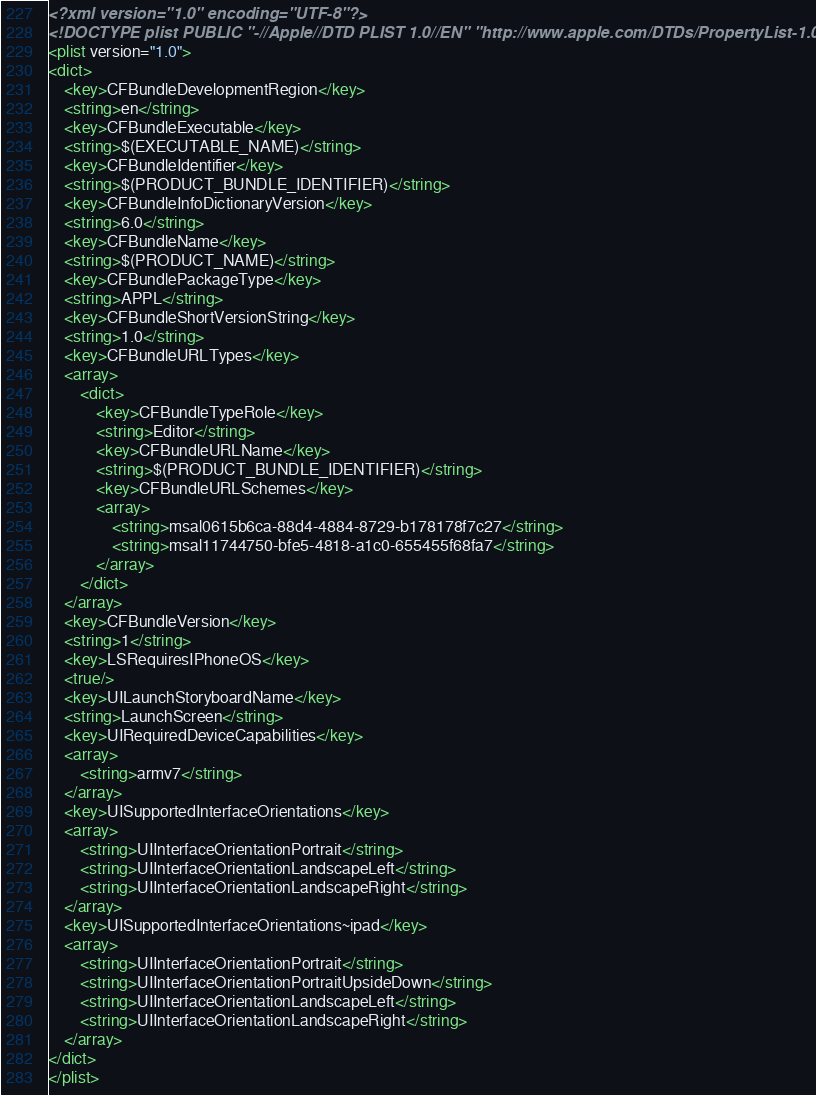<code> <loc_0><loc_0><loc_500><loc_500><_XML_><?xml version="1.0" encoding="UTF-8"?>
<!DOCTYPE plist PUBLIC "-//Apple//DTD PLIST 1.0//EN" "http://www.apple.com/DTDs/PropertyList-1.0.dtd">
<plist version="1.0">
<dict>
	<key>CFBundleDevelopmentRegion</key>
	<string>en</string>
	<key>CFBundleExecutable</key>
	<string>$(EXECUTABLE_NAME)</string>
	<key>CFBundleIdentifier</key>
	<string>$(PRODUCT_BUNDLE_IDENTIFIER)</string>
	<key>CFBundleInfoDictionaryVersion</key>
	<string>6.0</string>
	<key>CFBundleName</key>
	<string>$(PRODUCT_NAME)</string>
	<key>CFBundlePackageType</key>
	<string>APPL</string>
	<key>CFBundleShortVersionString</key>
	<string>1.0</string>
	<key>CFBundleURLTypes</key>
	<array>
		<dict>
			<key>CFBundleTypeRole</key>
			<string>Editor</string>
			<key>CFBundleURLName</key>
			<string>$(PRODUCT_BUNDLE_IDENTIFIER)</string>
			<key>CFBundleURLSchemes</key>
			<array>
				<string>msal0615b6ca-88d4-4884-8729-b178178f7c27</string>
				<string>msal11744750-bfe5-4818-a1c0-655455f68fa7</string>
			</array>
		</dict>
	</array>
	<key>CFBundleVersion</key>
	<string>1</string>
	<key>LSRequiresIPhoneOS</key>
	<true/>
	<key>UILaunchStoryboardName</key>
	<string>LaunchScreen</string>
	<key>UIRequiredDeviceCapabilities</key>
	<array>
		<string>armv7</string>
	</array>
	<key>UISupportedInterfaceOrientations</key>
	<array>
		<string>UIInterfaceOrientationPortrait</string>
		<string>UIInterfaceOrientationLandscapeLeft</string>
		<string>UIInterfaceOrientationLandscapeRight</string>
	</array>
	<key>UISupportedInterfaceOrientations~ipad</key>
	<array>
		<string>UIInterfaceOrientationPortrait</string>
		<string>UIInterfaceOrientationPortraitUpsideDown</string>
		<string>UIInterfaceOrientationLandscapeLeft</string>
		<string>UIInterfaceOrientationLandscapeRight</string>
	</array>
</dict>
</plist>
</code> 